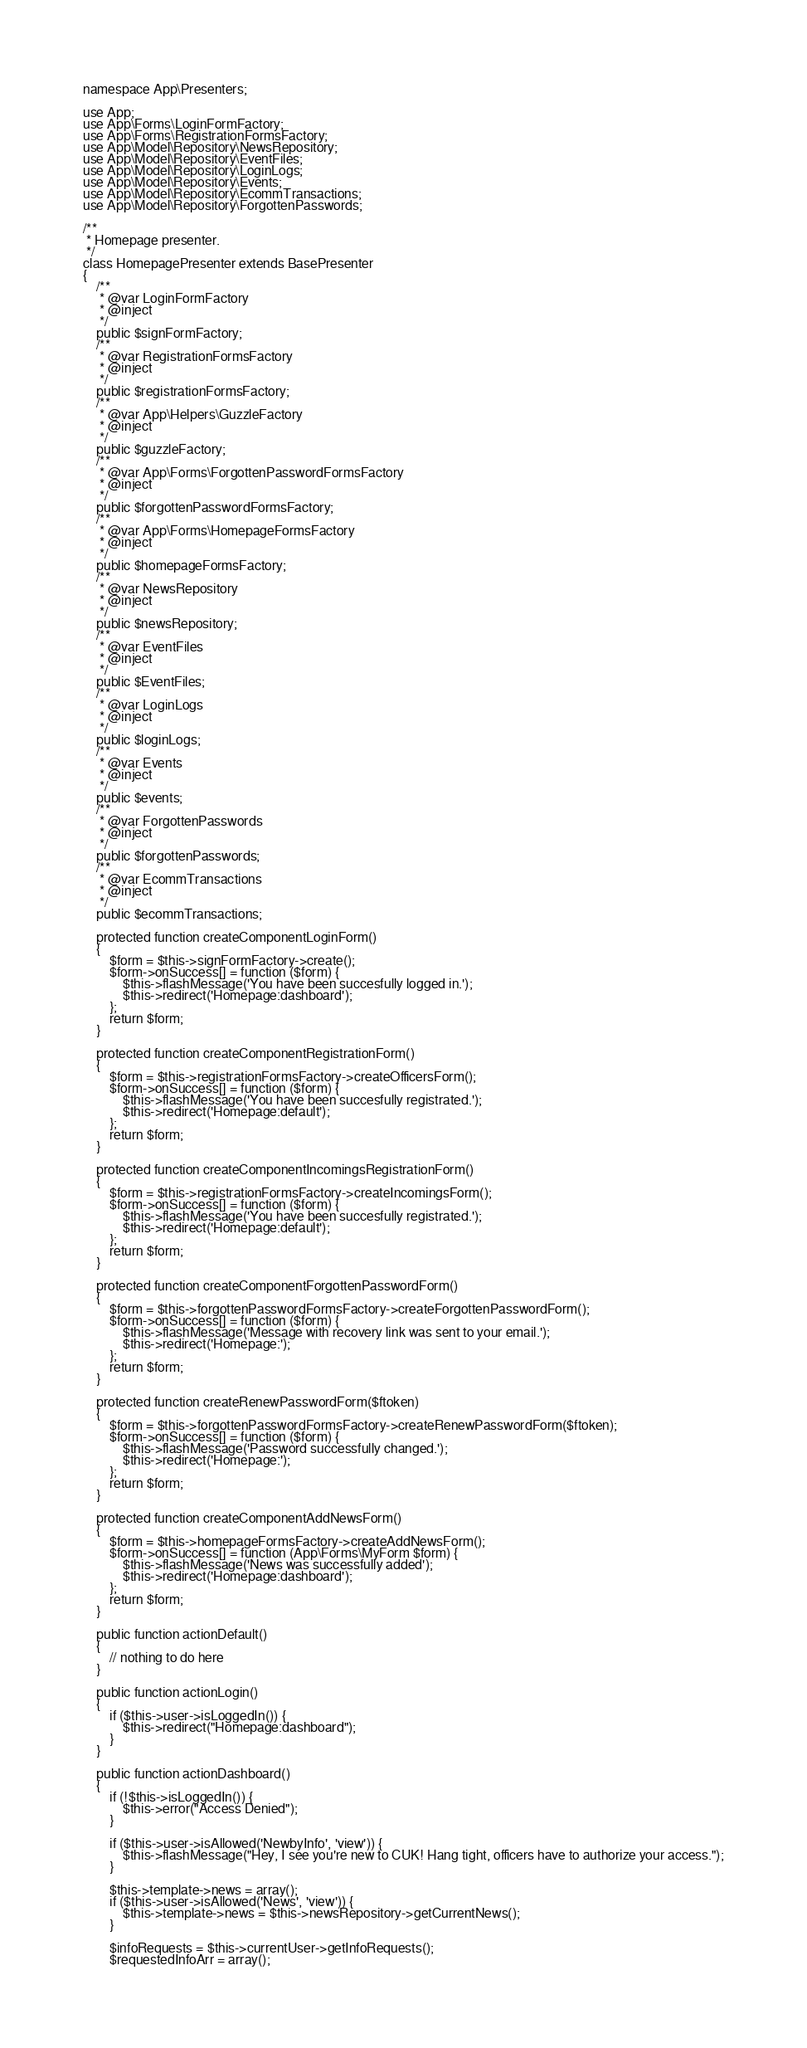<code> <loc_0><loc_0><loc_500><loc_500><_PHP_>namespace App\Presenters;

use App;
use App\Forms\LoginFormFactory;
use App\Forms\RegistrationFormsFactory;
use App\Model\Repository\NewsRepository;
use App\Model\Repository\EventFiles;
use App\Model\Repository\LoginLogs;
use App\Model\Repository\Events;
use App\Model\Repository\EcommTransactions;
use App\Model\Repository\ForgottenPasswords;

/**
 * Homepage presenter.
 */
class HomepagePresenter extends BasePresenter
{
    /**
     * @var LoginFormFactory
     * @inject
     */
    public $signFormFactory;
    /**
     * @var RegistrationFormsFactory
     * @inject
     */
    public $registrationFormsFactory;
    /**
     * @var App\Helpers\GuzzleFactory
     * @inject
     */
    public $guzzleFactory;
    /**
     * @var App\Forms\ForgottenPasswordFormsFactory
     * @inject
     */
    public $forgottenPasswordFormsFactory;
    /**
     * @var App\Forms\HomepageFormsFactory
     * @inject
     */
    public $homepageFormsFactory;
    /**
     * @var NewsRepository
     * @inject
     */
    public $newsRepository;
    /**
     * @var EventFiles
     * @inject
     */
    public $EventFiles;
    /**
     * @var LoginLogs
     * @inject
     */
    public $loginLogs;
    /**
     * @var Events
     * @inject
     */
    public $events;
    /**
     * @var ForgottenPasswords
     * @inject
     */
    public $forgottenPasswords;
    /**
     * @var EcommTransactions
     * @inject
     */
    public $ecommTransactions;

    protected function createComponentLoginForm()
    {
        $form = $this->signFormFactory->create();
        $form->onSuccess[] = function ($form) {
            $this->flashMessage('You have been succesfully logged in.');
            $this->redirect('Homepage:dashboard');
        };
        return $form;
    }

    protected function createComponentRegistrationForm()
    {
        $form = $this->registrationFormsFactory->createOfficersForm();
        $form->onSuccess[] = function ($form) {
            $this->flashMessage('You have been succesfully registrated.');
            $this->redirect('Homepage:default');
        };
        return $form;
    }

    protected function createComponentIncomingsRegistrationForm()
    {
        $form = $this->registrationFormsFactory->createIncomingsForm();
        $form->onSuccess[] = function ($form) {
            $this->flashMessage('You have been succesfully registrated.');
            $this->redirect('Homepage:default');
        };
        return $form;
    }

    protected function createComponentForgottenPasswordForm()
    {
        $form = $this->forgottenPasswordFormsFactory->createForgottenPasswordForm();
        $form->onSuccess[] = function ($form) {
            $this->flashMessage('Message with recovery link was sent to your email.');
            $this->redirect('Homepage:');
        };
        return $form;
    }

    protected function createRenewPasswordForm($ftoken)
    {
        $form = $this->forgottenPasswordFormsFactory->createRenewPasswordForm($ftoken);
        $form->onSuccess[] = function ($form) {
            $this->flashMessage('Password successfully changed.');
            $this->redirect('Homepage:');
        };
        return $form;
    }

    protected function createComponentAddNewsForm()
    {
        $form = $this->homepageFormsFactory->createAddNewsForm();
        $form->onSuccess[] = function (App\Forms\MyForm $form) {
            $this->flashMessage('News was successfully added');
            $this->redirect('Homepage:dashboard');
        };
        return $form;
    }

    public function actionDefault()
    {
        // nothing to do here
    }

    public function actionLogin()
    {
        if ($this->user->isLoggedIn()) {
            $this->redirect("Homepage:dashboard");
        }
    }

    public function actionDashboard()
    {
        if (!$this->isLoggedIn()) {
            $this->error("Access Denied");
        }

        if ($this->user->isAllowed('NewbyInfo', 'view')) {
            $this->flashMessage("Hey, I see you're new to CUK! Hang tight, officers have to authorize your access.");
        }

        $this->template->news = array();
        if ($this->user->isAllowed('News', 'view')) {
            $this->template->news = $this->newsRepository->getCurrentNews();
        }

        $infoRequests = $this->currentUser->getInfoRequests();
        $requestedInfoArr = array();</code> 